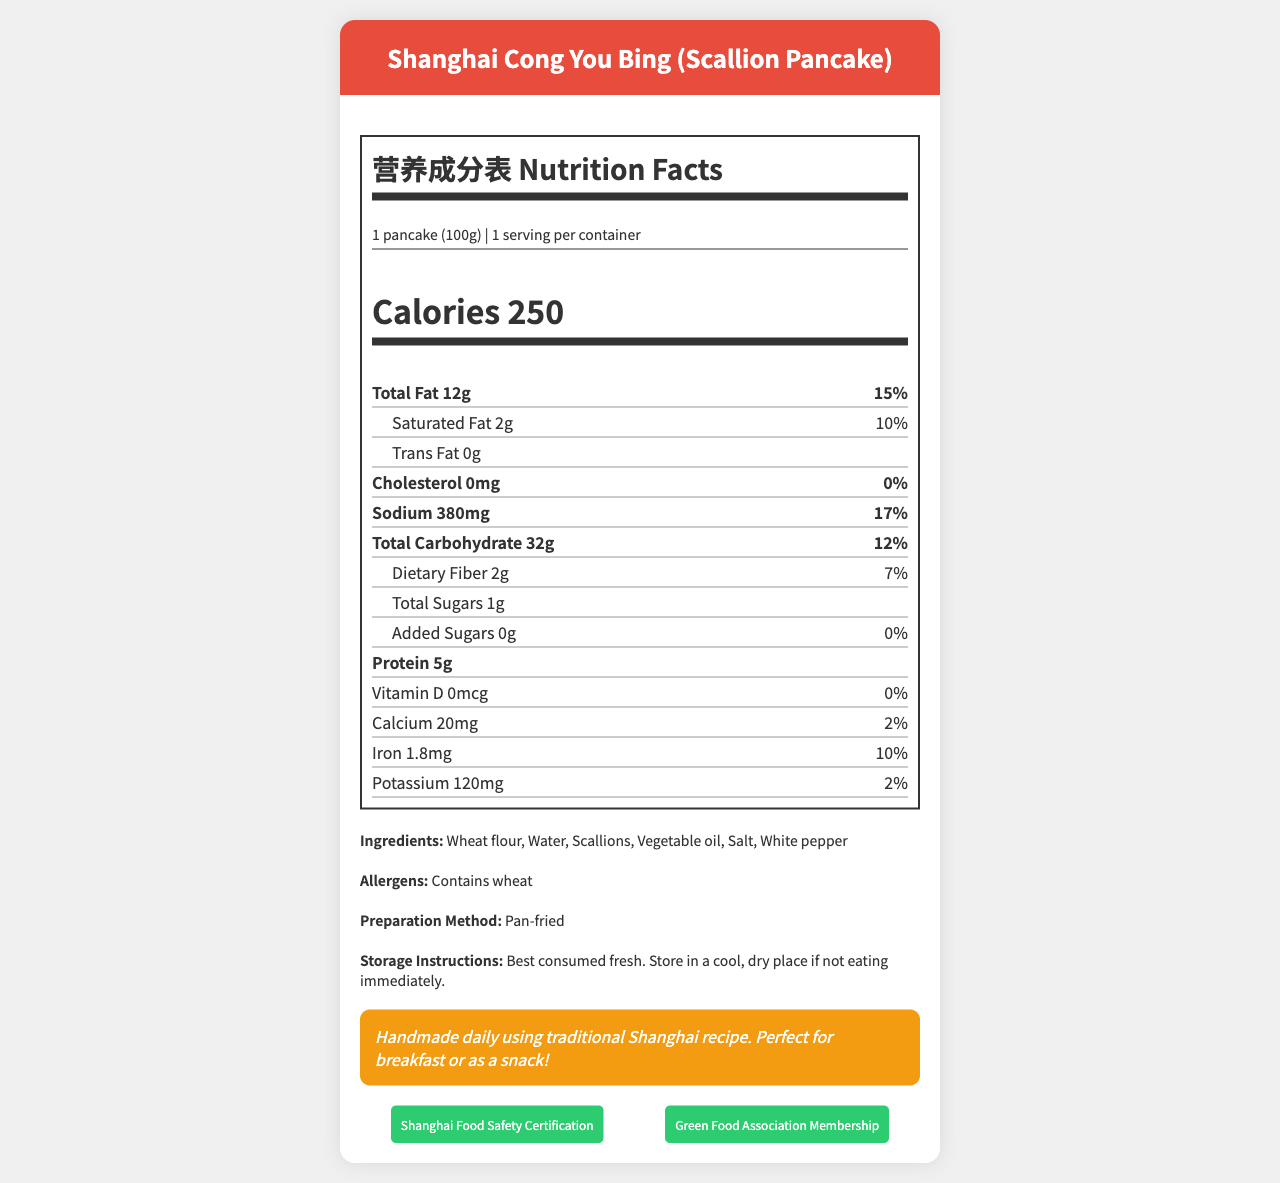What is the serving size for Shanghai Cong You Bing? The document lists the serving size clearly under the nutrition facts section.
Answer: 1 pancake (100g) How many calories are in one serving of the scallion pancake? The nutrition facts section provides the calories per serving right at the top.
Answer: 250 What is the total fat content per serving? This information is listed under the total fat entry in the nutrition facts segment.
Answer: 12g How much sodium is there in one serving of the pancake? The nutrition facts section lists the sodium content along with its daily value percentage.
Answer: 380mg What are the main ingredients in the scallion pancake? The ingredients section details all the main components used.
Answer: Wheat flour, Water, Scallions, Vegetable oil, Salt, White pepper What percentage of daily value is the saturated fat content? The nutrition facts section lists the daily value percentage next to the saturated fat content.
Answer: 10% Which vitamin has a 0% daily value in the scallion pancake? A. Vitamin D B. Vitamin C C. Vitamin A D. Vitamin B12 The vitamin section of the label shows that Vitamin D has a 0% daily value.
Answer: A How many grams of protein are in one serving of the scallion pancake? This information is listed under the protein entry in the nutrition facts.
Answer: 5g Is there any trans fat in the scallion pancake? (Yes/No) The nutrition facts state that there is 0g of trans fat.
Answer: No In addition to sodium, which other mineral contributes significantly to the daily value percentage? A. Calcium B. Iron C. Potassium The Iron content has a significant daily value of 10%, compared to 2% for Calcium and Potassium.
Answer: B. Iron What certifications does the vendor have for the scallion pancake? This information is listed in the documentation under local certifications.
Answer: Shanghai Food Safety Certification, Green Food Association Membership Are there any added sugars in the scallion pancake? The nutrition facts show 0g of added sugars.
Answer: No Is the scallion pancake suitable for people with wheat allergies? (Yes/No) The allergens section lists that it contains wheat.
Answer: No Describe the main idea of the document. This summary encapsulates the comprehensive nutritional and product details given in the document, making it useful for both consumers and regulatory purposes.
Answer: The document provides detailed nutrition facts, ingredient information, allergen warnings, preparation methods, and storage instructions for Shanghai Cong You Bing, along with vendor notes and certifications. How is the scallion pancake prepared? The preparation method is described in the document.
Answer: Pan-fried How should the scallion pancake be stored if not consumed immediately? The storage instructions provide this information.
Answer: Store in a cool, dry place Can you determine the price of the scallion pancake from the document? The document does not provide any information regarding the price of the scallion pancake.
Answer: Cannot be determined 